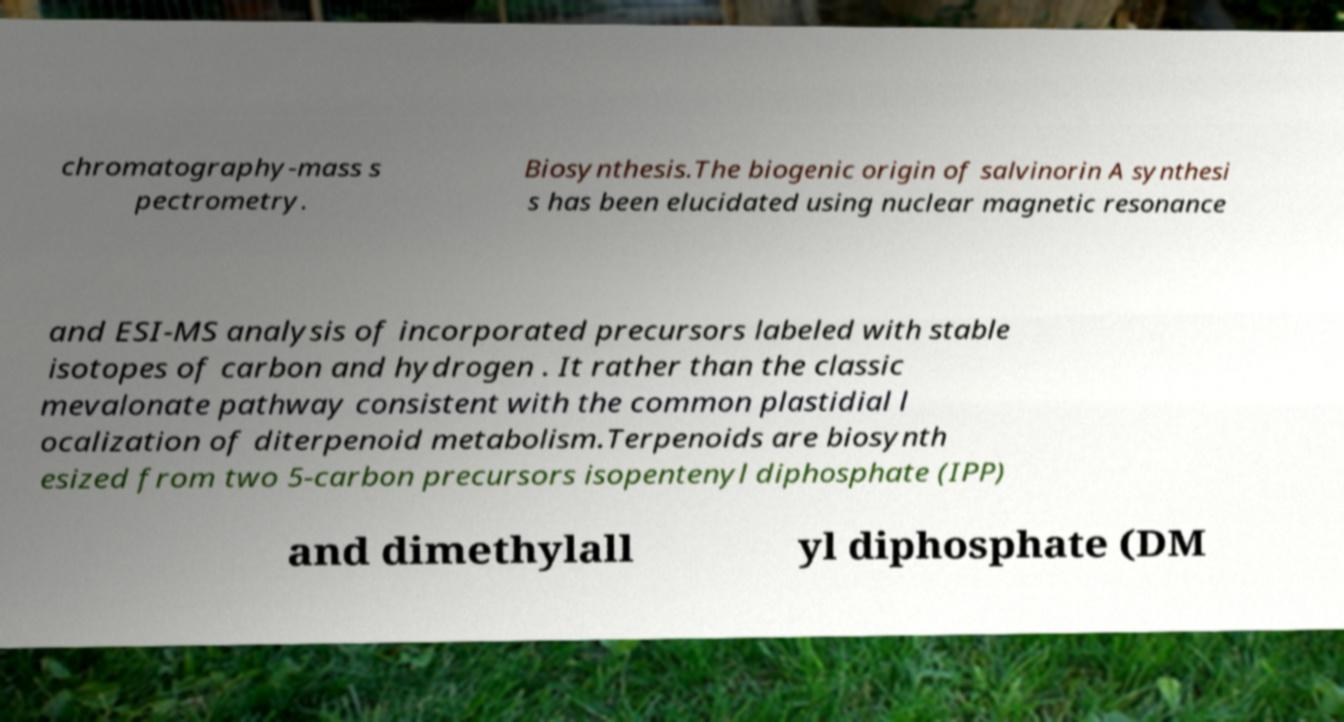What messages or text are displayed in this image? I need them in a readable, typed format. chromatography-mass s pectrometry. Biosynthesis.The biogenic origin of salvinorin A synthesi s has been elucidated using nuclear magnetic resonance and ESI-MS analysis of incorporated precursors labeled with stable isotopes of carbon and hydrogen . It rather than the classic mevalonate pathway consistent with the common plastidial l ocalization of diterpenoid metabolism.Terpenoids are biosynth esized from two 5-carbon precursors isopentenyl diphosphate (IPP) and dimethylall yl diphosphate (DM 